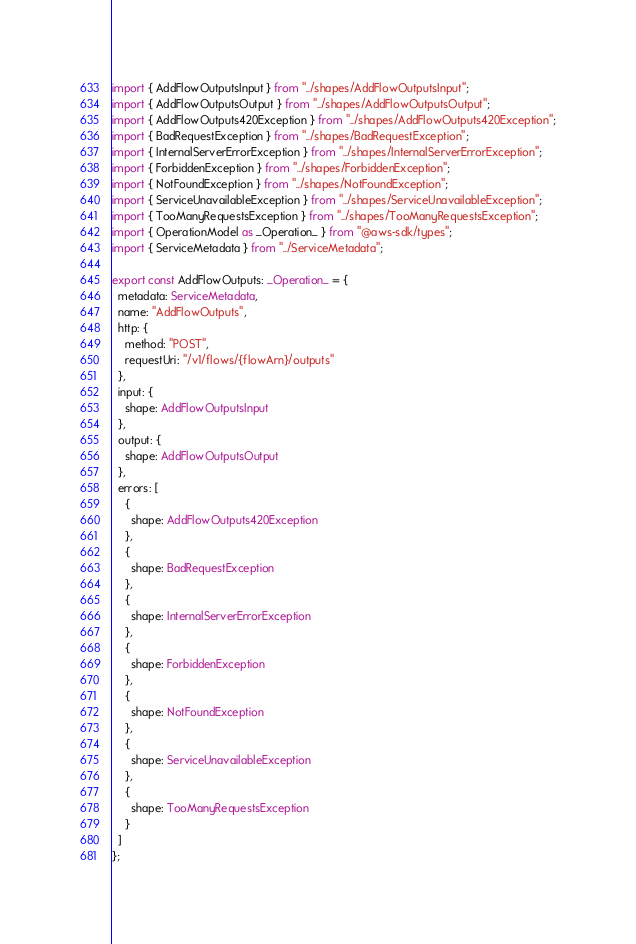Convert code to text. <code><loc_0><loc_0><loc_500><loc_500><_TypeScript_>import { AddFlowOutputsInput } from "../shapes/AddFlowOutputsInput";
import { AddFlowOutputsOutput } from "../shapes/AddFlowOutputsOutput";
import { AddFlowOutputs420Exception } from "../shapes/AddFlowOutputs420Exception";
import { BadRequestException } from "../shapes/BadRequestException";
import { InternalServerErrorException } from "../shapes/InternalServerErrorException";
import { ForbiddenException } from "../shapes/ForbiddenException";
import { NotFoundException } from "../shapes/NotFoundException";
import { ServiceUnavailableException } from "../shapes/ServiceUnavailableException";
import { TooManyRequestsException } from "../shapes/TooManyRequestsException";
import { OperationModel as _Operation_ } from "@aws-sdk/types";
import { ServiceMetadata } from "../ServiceMetadata";

export const AddFlowOutputs: _Operation_ = {
  metadata: ServiceMetadata,
  name: "AddFlowOutputs",
  http: {
    method: "POST",
    requestUri: "/v1/flows/{flowArn}/outputs"
  },
  input: {
    shape: AddFlowOutputsInput
  },
  output: {
    shape: AddFlowOutputsOutput
  },
  errors: [
    {
      shape: AddFlowOutputs420Exception
    },
    {
      shape: BadRequestException
    },
    {
      shape: InternalServerErrorException
    },
    {
      shape: ForbiddenException
    },
    {
      shape: NotFoundException
    },
    {
      shape: ServiceUnavailableException
    },
    {
      shape: TooManyRequestsException
    }
  ]
};
</code> 